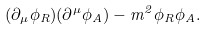<formula> <loc_0><loc_0><loc_500><loc_500>( \partial _ { \mu } \phi _ { R } ) ( \partial ^ { \mu } \phi _ { A } ) - m ^ { 2 } \phi _ { R } \phi _ { A } .</formula> 